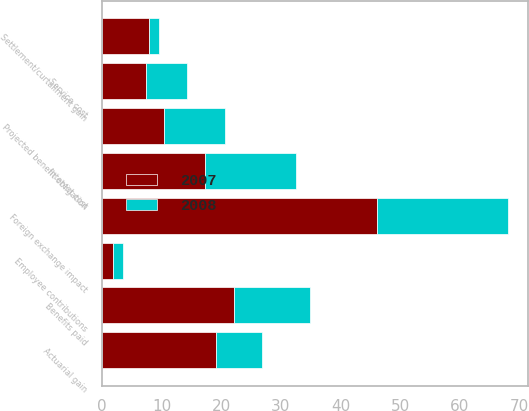Convert chart. <chart><loc_0><loc_0><loc_500><loc_500><stacked_bar_chart><ecel><fcel>Projected benefit obligation<fcel>Service cost<fcel>Interest cost<fcel>Actuarial gain<fcel>Settlement/curtailment gain<fcel>Benefits paid<fcel>Employee contributions<fcel>Foreign exchange impact<nl><fcel>2007<fcel>10.35<fcel>7.4<fcel>17.2<fcel>19.1<fcel>7.9<fcel>22.1<fcel>1.8<fcel>46.1<nl><fcel>2008<fcel>10.35<fcel>6.9<fcel>15.3<fcel>7.7<fcel>1.7<fcel>12.8<fcel>1.7<fcel>21.9<nl></chart> 